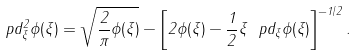Convert formula to latex. <formula><loc_0><loc_0><loc_500><loc_500>\ p d _ { \xi } ^ { 2 } \phi ( \xi ) = \sqrt { \frac { 2 } { \pi } \phi ( \xi ) } - \left [ 2 \phi ( \xi ) - \frac { 1 } { 2 } \xi \ p d _ { \xi } \phi ( \xi ) \right ] ^ { - 1 / 2 } .</formula> 